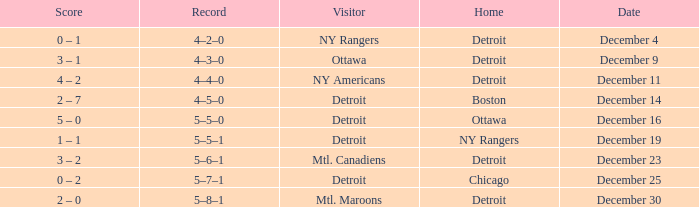What score has detroit as the home, and December 9 as the date? 3 – 1. 